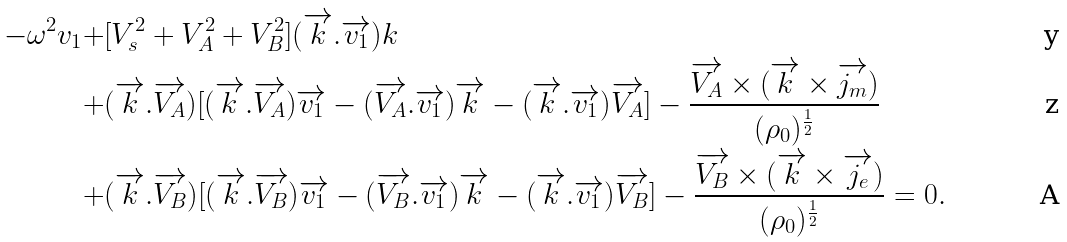Convert formula to latex. <formula><loc_0><loc_0><loc_500><loc_500>- \omega ^ { 2 } v _ { 1 } + & [ V _ { s } ^ { 2 } + V _ { A } ^ { 2 } + V _ { B } ^ { 2 } ] ( \overrightarrow { k } . \overrightarrow { v _ { 1 } } ) k \\ + & ( \overrightarrow { k } . \overrightarrow { V _ { A } } ) [ ( \overrightarrow { k } . \overrightarrow { V _ { A } } ) \overrightarrow { v _ { 1 } } - ( \overrightarrow { V _ { A } } . \overrightarrow { v _ { 1 } } ) \overrightarrow { k } - ( \overrightarrow { k } . \overrightarrow { v _ { 1 } } ) \overrightarrow { V _ { A } } ] - \frac { \overrightarrow { V _ { A } } \times ( \overrightarrow { k } \times \overrightarrow { j _ { m } } ) } { ( \rho _ { 0 } ) ^ { \frac { 1 } { 2 } } } \\ + & ( \overrightarrow { k } . \overrightarrow { V _ { B } } ) [ ( \overrightarrow { k } . \overrightarrow { V _ { B } } ) \overrightarrow { v _ { 1 } } - ( \overrightarrow { V _ { B } } . \overrightarrow { v _ { 1 } } ) \overrightarrow { k } - ( \overrightarrow { k } . \overrightarrow { v _ { 1 } } ) \overrightarrow { V _ { B } } ] - \frac { \overrightarrow { V _ { B } } \times ( \overrightarrow { k } \times \overrightarrow { j _ { e } } ) } { ( \rho _ { 0 } ) ^ { \frac { 1 } { 2 } } } = 0 .</formula> 